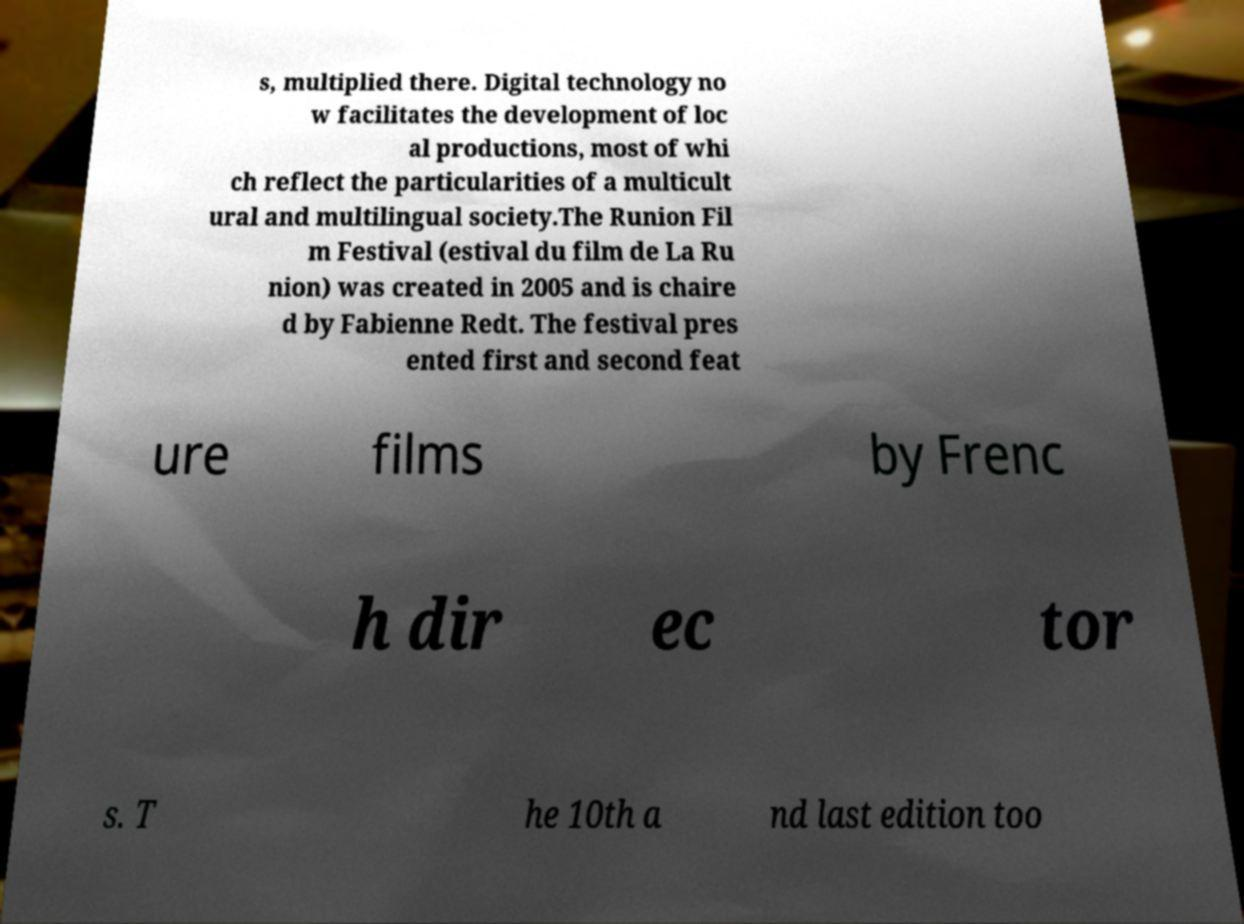Can you read and provide the text displayed in the image?This photo seems to have some interesting text. Can you extract and type it out for me? s, multiplied there. Digital technology no w facilitates the development of loc al productions, most of whi ch reflect the particularities of a multicult ural and multilingual society.The Runion Fil m Festival (estival du film de La Ru nion) was created in 2005 and is chaire d by Fabienne Redt. The festival pres ented first and second feat ure films by Frenc h dir ec tor s. T he 10th a nd last edition too 